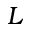Convert formula to latex. <formula><loc_0><loc_0><loc_500><loc_500>L</formula> 